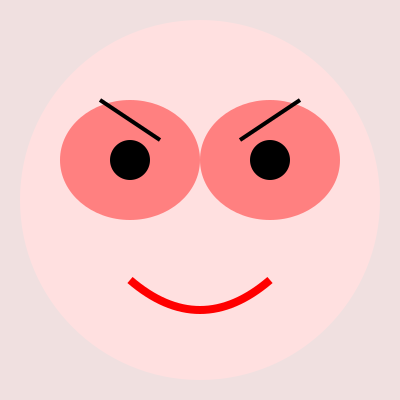Which iconic Melanie Martinez makeup look is represented in this close-up image? To identify this iconic Melanie Martinez makeup look, let's analyze the key elements:

1. Face shape: The overall face shape is round, represented by the large circle.
2. Eye makeup: There are two large, exaggerated eye shapes in a bright pink color (#ff8080).
3. Eye details: Within each eye shape, there's a smaller black circle, representing enlarged pupils or dark eye makeup.
4. Eyebrows: Above each eye, there's a thick, angled line representing bold, dramatic eyebrows.
5. Lips: At the bottom of the face, there's a curved red line representing a bright red lip color.
6. Blush: The overall face has a pink tint (#ffe0e0), suggesting heavy blush application.

These elements combined create a doll-like, exaggerated appearance that is characteristic of Melanie Martinez's "Cry Baby" era makeup look. This look is often associated with her debut album and the character she created for it.

The oversized eyes, bold brows, and bright lip color are all hallmarks of the "Cry Baby" aesthetic, which draws inspiration from vintage dolls and childlike imagery while incorporating a darker, more mature twist.
Answer: Cry Baby look 